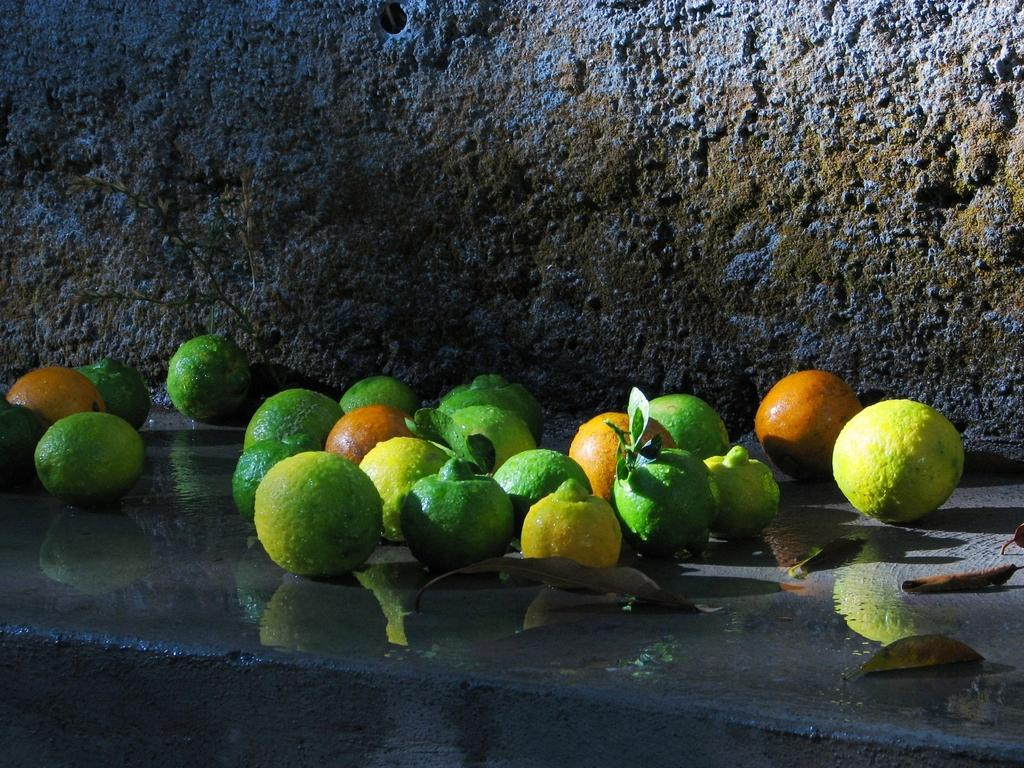What type of food items can be seen in the image? There are fruits in the image. What else is present in the image besides the fruits? There are leaves in the image. What is the water situated on in the image? The water is on a platform in the image. What can be seen in the distance in the image? There is a wall visible in the background of the image. What type of vegetable is being used as a wristband in the image? There is no vegetable being used as a wristband in the image. What activity is taking place in the image? The image does not depict any specific activity; it simply shows fruits, leaves, water on a platform, and a wall in the background. 